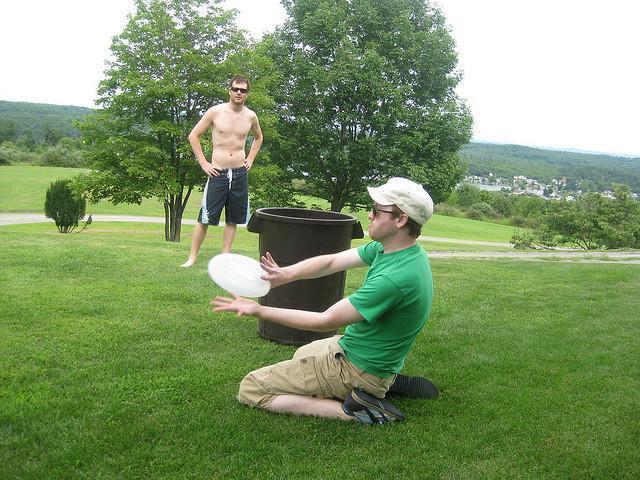What is the man wearing a hat doing?
Answer the question by selecting the correct answer among the 4 following choices and explain your choice with a short sentence. The answer should be formatted with the following format: `Answer: choice
Rationale: rationale.`
Options: Playing roshambo, holding plate, catching frisbee, throwing frisbee. Answer: catching frisbee.
Rationale: The man with the hat is holding out his hands to catch a frisbee. 